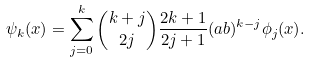<formula> <loc_0><loc_0><loc_500><loc_500>\psi _ { k } ( x ) = \sum _ { j = 0 } ^ { k } \binom { k + j } { 2 j } \frac { 2 k + 1 } { 2 j + 1 } ( a b ) ^ { k - j } \phi _ { j } ( x ) .</formula> 